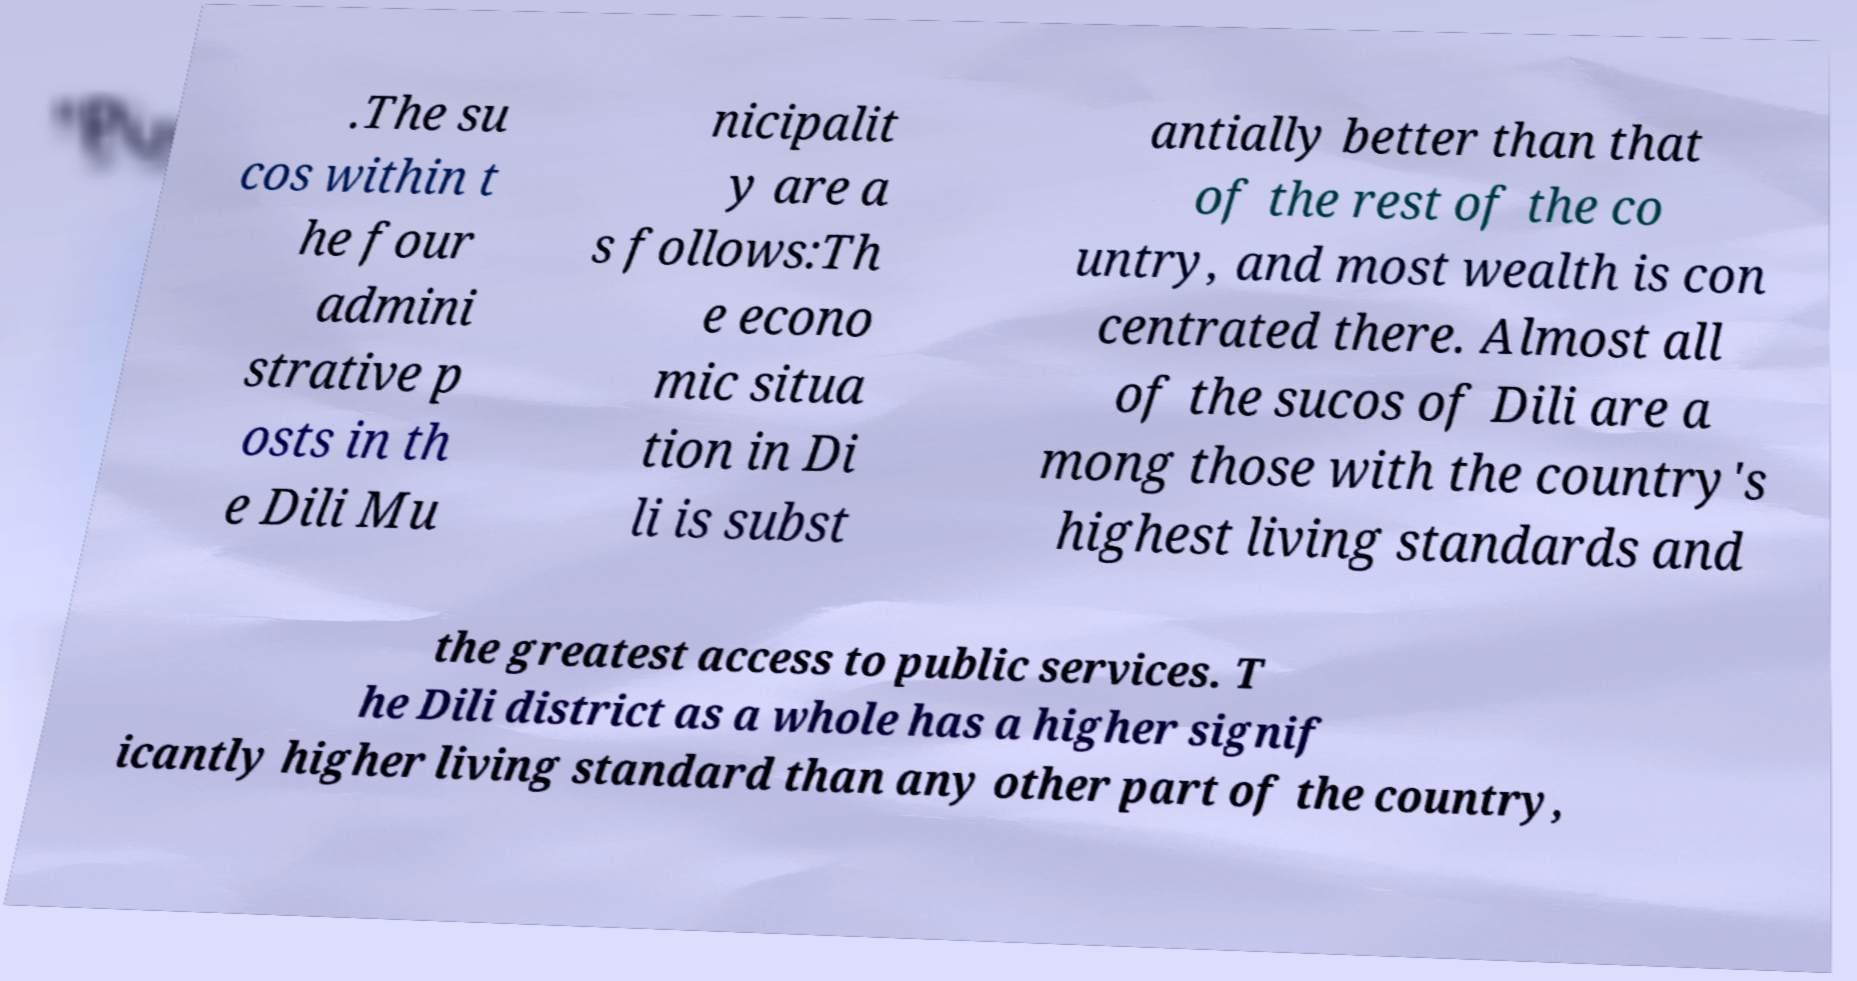Could you extract and type out the text from this image? .The su cos within t he four admini strative p osts in th e Dili Mu nicipalit y are a s follows:Th e econo mic situa tion in Di li is subst antially better than that of the rest of the co untry, and most wealth is con centrated there. Almost all of the sucos of Dili are a mong those with the country's highest living standards and the greatest access to public services. T he Dili district as a whole has a higher signif icantly higher living standard than any other part of the country, 